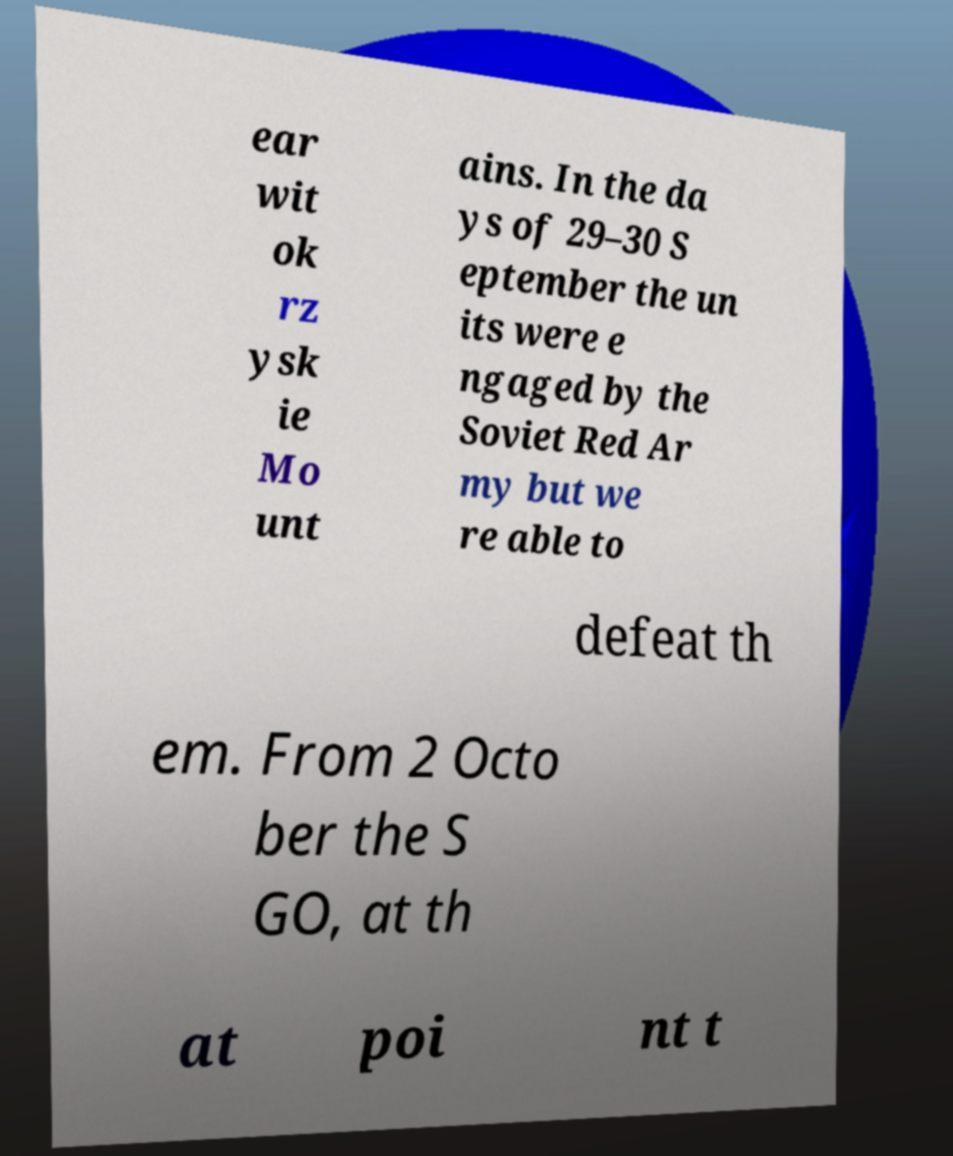Could you assist in decoding the text presented in this image and type it out clearly? ear wit ok rz ysk ie Mo unt ains. In the da ys of 29–30 S eptember the un its were e ngaged by the Soviet Red Ar my but we re able to defeat th em. From 2 Octo ber the S GO, at th at poi nt t 